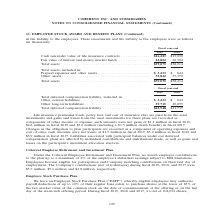According to Coherent's financial document, What was the Total deferred compensation liability in 2019? According to the financial document, $42,948 (in thousands). The relevant text states: "Total deferred compensation liability . $42,948 $41,739..." Also, What was the  Other long-term liabilities  in 2018? According to the financial document, 40,895 (in thousands). The relevant text states: "3,233 $ 844 Other long-term liabilities . 39,715 40,895..." Also, In which years was Total deferred compensation liability calculated? The document shows two values: 2019 and 2018. From the document: "Fiscal year-end 2019 2018 Fiscal year-end 2019 2018..." Additionally, In which year was Other long-term liabilities larger? According to the financial document, 2018. The relevant text states: "Fiscal year-end 2019 2018..." Also, can you calculate: What was the change in Other current liabilities from 2018 to 2019? Based on the calculation: 3,233-844, the result is 2389 (in thousands). This is based on the information: "ncluded in: Prepaid expenses and other assets . $ 3,233 $ 844 Other assets . 35,842 37,370 in: Prepaid expenses and other assets . $ 3,233 $ 844 Other assets . 35,842 37,370..." The key data points involved are: 3,233, 844. Also, can you calculate: What was the percentage change in Other current liabilities from 2018 to 2019? To answer this question, I need to perform calculations using the financial data. The calculation is: (3,233-844)/844, which equals 283.06 (percentage). This is based on the information: "ncluded in: Prepaid expenses and other assets . $ 3,233 $ 844 Other assets . 35,842 37,370 in: Prepaid expenses and other assets . $ 3,233 $ 844 Other assets . 35,842 37,370..." The key data points involved are: 3,233, 844. 